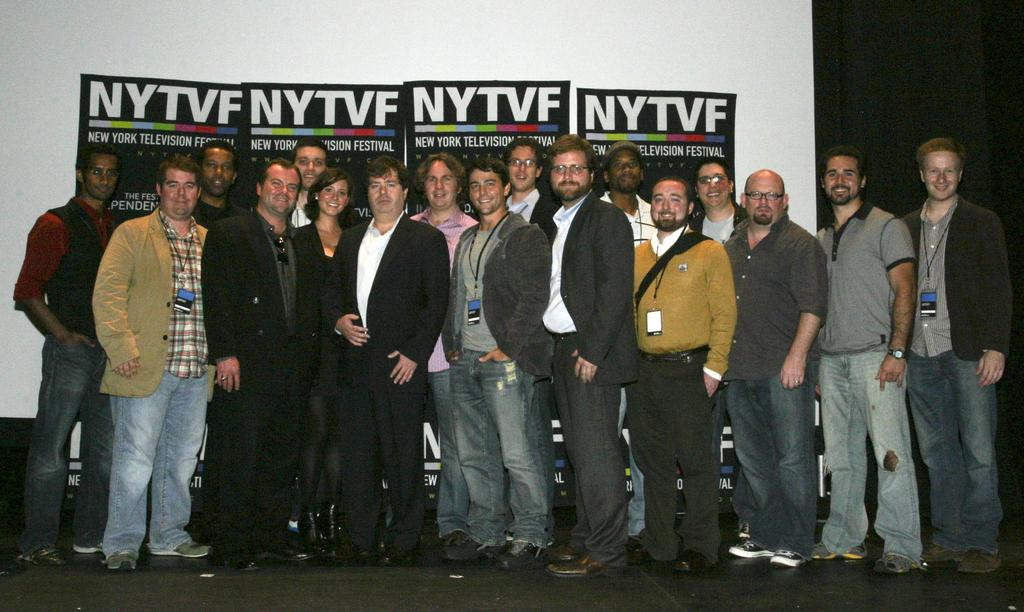What are the people in the image doing? The people in the image are standing on the floor. What can be seen on the wall in the background of the image? There are posters on the wall in the background of the image. How many apples are being held by the people in the image? There is no mention of apples in the image, so it cannot be determined how many apples are being held. 